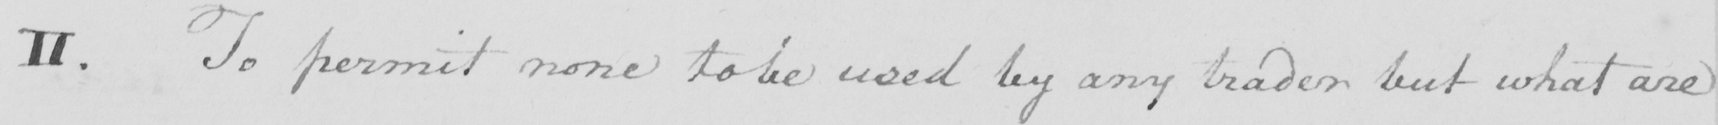Please transcribe the handwritten text in this image. II. To permit none to be used by any trader but what are 